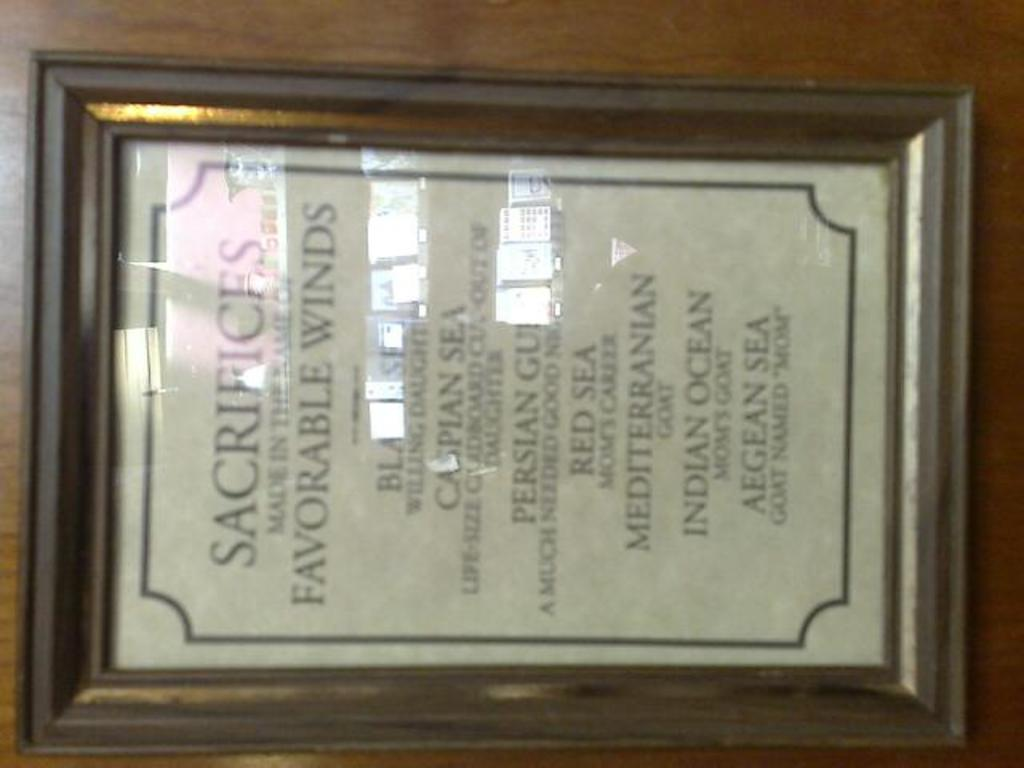Provide a one-sentence caption for the provided image. A framed poem lists the oceans of one part of the world. 